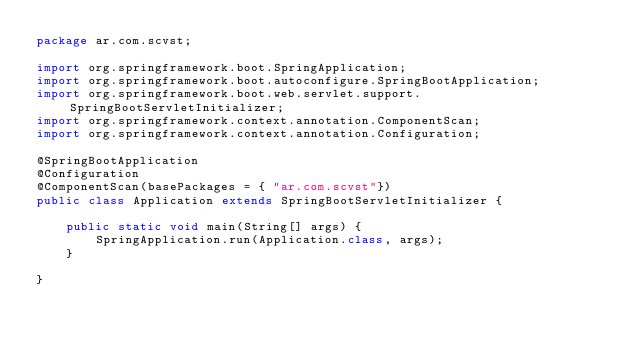Convert code to text. <code><loc_0><loc_0><loc_500><loc_500><_Java_>package ar.com.scvst;

import org.springframework.boot.SpringApplication;
import org.springframework.boot.autoconfigure.SpringBootApplication;
import org.springframework.boot.web.servlet.support.SpringBootServletInitializer;
import org.springframework.context.annotation.ComponentScan;
import org.springframework.context.annotation.Configuration;

@SpringBootApplication
@Configuration
@ComponentScan(basePackages = { "ar.com.scvst"})
public class Application extends SpringBootServletInitializer {

    public static void main(String[] args) {
        SpringApplication.run(Application.class, args);
    }

}
</code> 